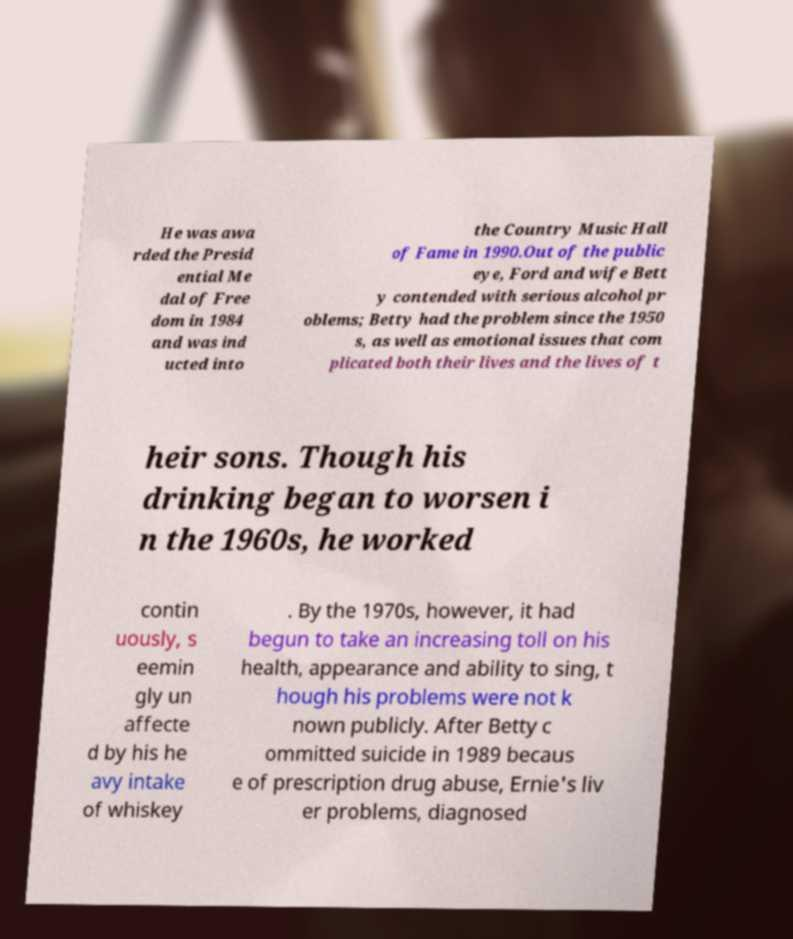I need the written content from this picture converted into text. Can you do that? He was awa rded the Presid ential Me dal of Free dom in 1984 and was ind ucted into the Country Music Hall of Fame in 1990.Out of the public eye, Ford and wife Bett y contended with serious alcohol pr oblems; Betty had the problem since the 1950 s, as well as emotional issues that com plicated both their lives and the lives of t heir sons. Though his drinking began to worsen i n the 1960s, he worked contin uously, s eemin gly un affecte d by his he avy intake of whiskey . By the 1970s, however, it had begun to take an increasing toll on his health, appearance and ability to sing, t hough his problems were not k nown publicly. After Betty c ommitted suicide in 1989 becaus e of prescription drug abuse, Ernie's liv er problems, diagnosed 